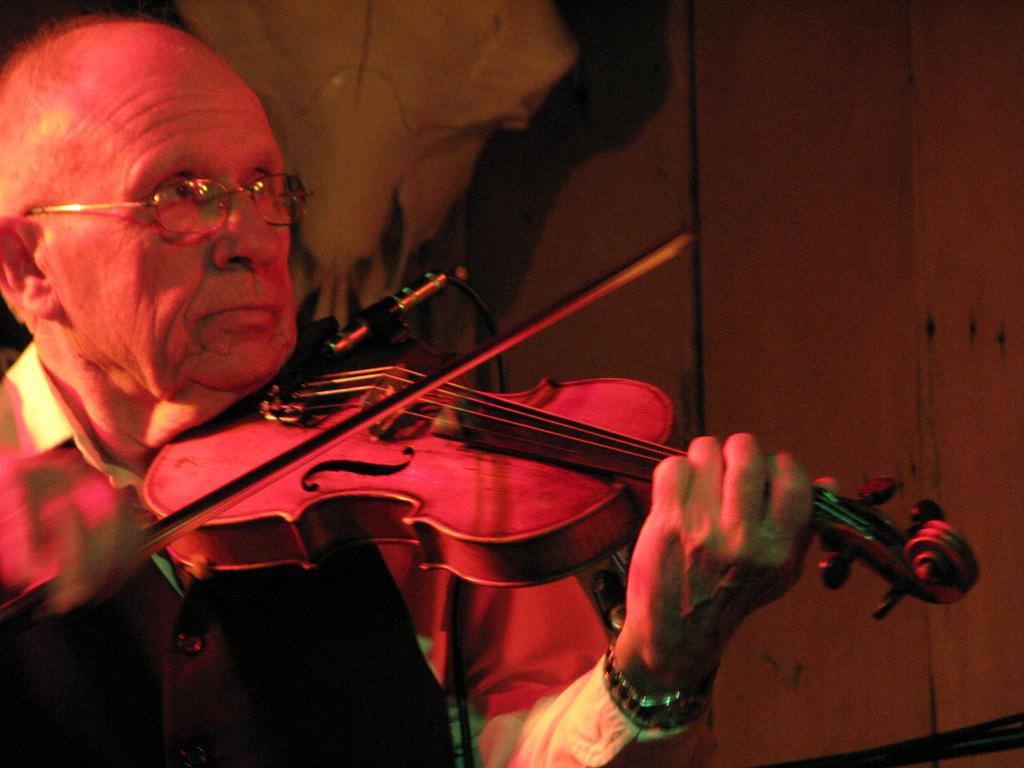Can you describe this image briefly? In this image I can see a man is playing violin in his hand. 